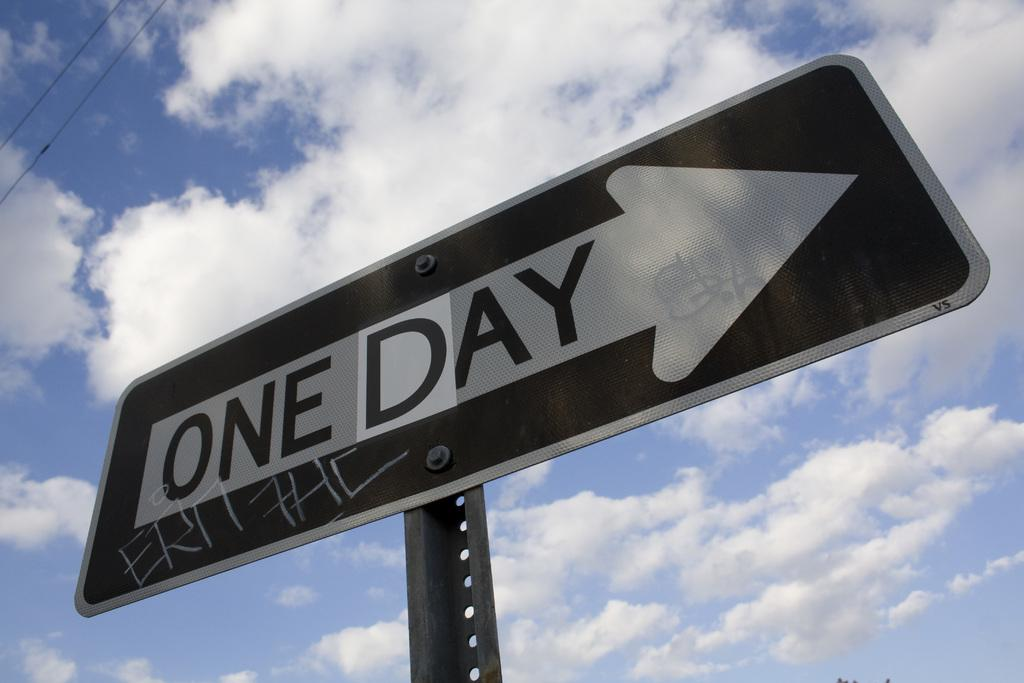Provide a one-sentence caption for the provided image. A one way sign has had the w replaced with a d so it says one day. 